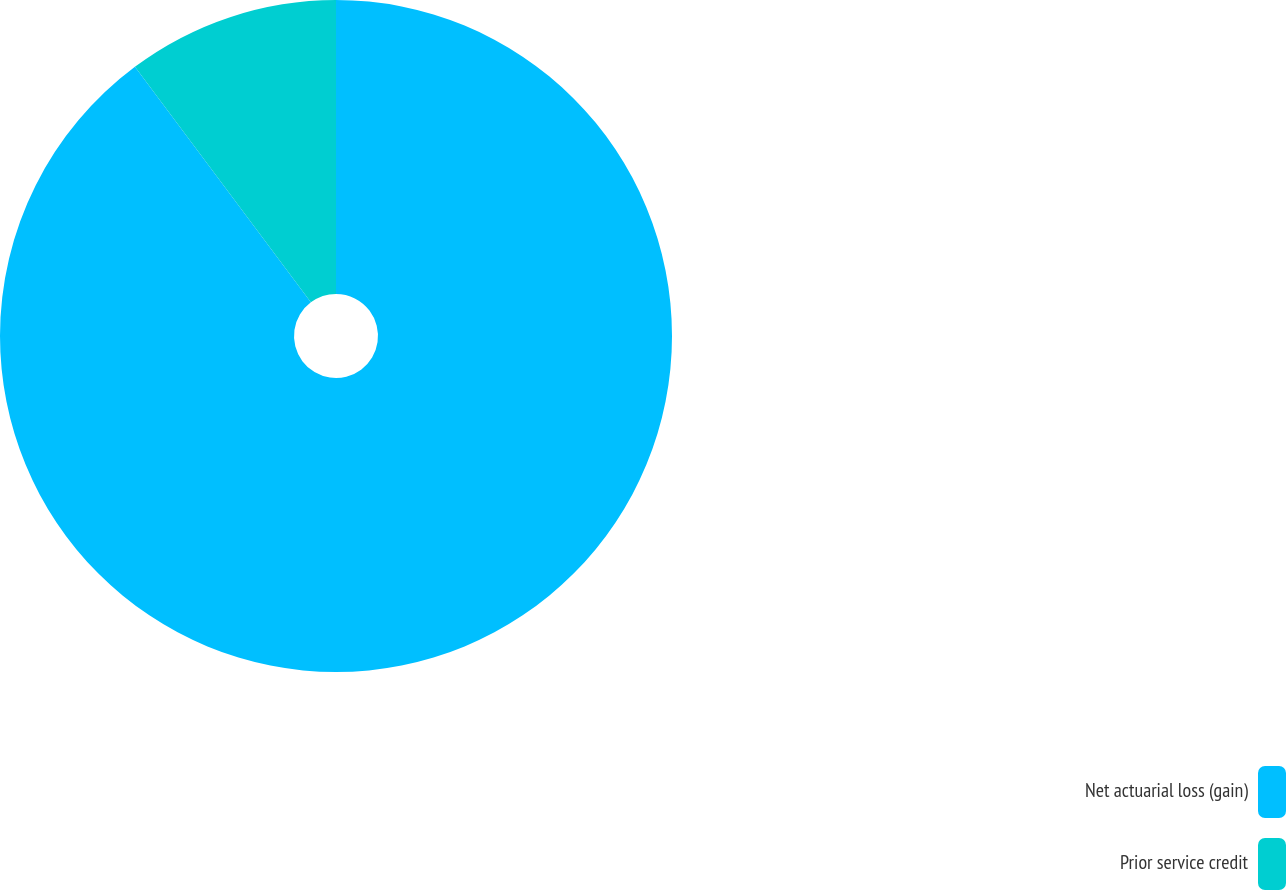Convert chart to OTSL. <chart><loc_0><loc_0><loc_500><loc_500><pie_chart><fcel>Net actuarial loss (gain)<fcel>Prior service credit<nl><fcel>89.79%<fcel>10.21%<nl></chart> 